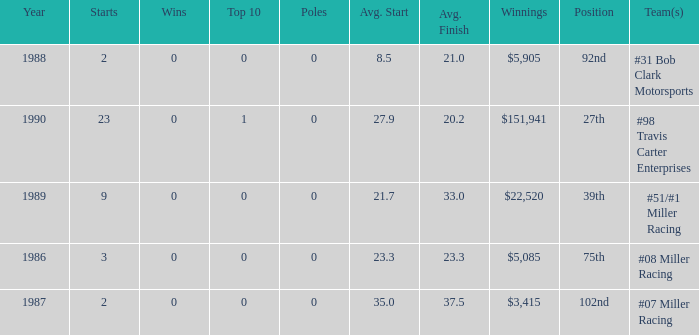What is the most recent year where the average start is 8.5? 1988.0. 